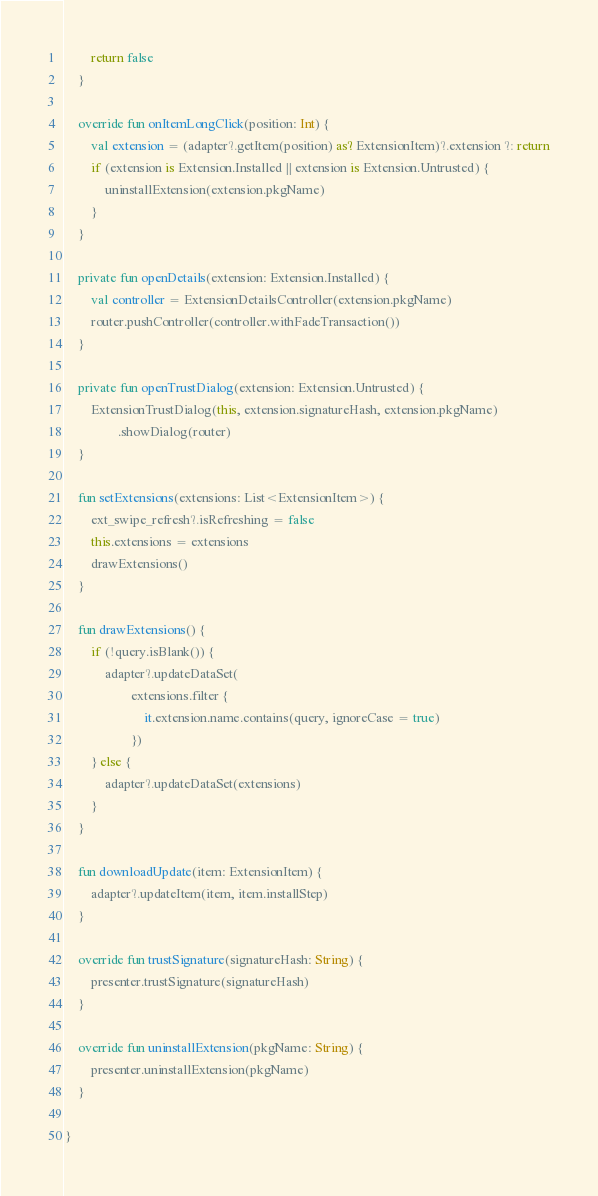<code> <loc_0><loc_0><loc_500><loc_500><_Kotlin_>
        return false
    }

    override fun onItemLongClick(position: Int) {
        val extension = (adapter?.getItem(position) as? ExtensionItem)?.extension ?: return
        if (extension is Extension.Installed || extension is Extension.Untrusted) {
            uninstallExtension(extension.pkgName)
        }
    }

    private fun openDetails(extension: Extension.Installed) {
        val controller = ExtensionDetailsController(extension.pkgName)
        router.pushController(controller.withFadeTransaction())
    }

    private fun openTrustDialog(extension: Extension.Untrusted) {
        ExtensionTrustDialog(this, extension.signatureHash, extension.pkgName)
                .showDialog(router)
    }

    fun setExtensions(extensions: List<ExtensionItem>) {
        ext_swipe_refresh?.isRefreshing = false
        this.extensions = extensions
        drawExtensions()
    }

    fun drawExtensions() {
        if (!query.isBlank()) {
            adapter?.updateDataSet(
                    extensions.filter {
                        it.extension.name.contains(query, ignoreCase = true)
                    })
        } else {
            adapter?.updateDataSet(extensions)
        }
    }

    fun downloadUpdate(item: ExtensionItem) {
        adapter?.updateItem(item, item.installStep)
    }

    override fun trustSignature(signatureHash: String) {
        presenter.trustSignature(signatureHash)
    }

    override fun uninstallExtension(pkgName: String) {
        presenter.uninstallExtension(pkgName)
    }

}
</code> 